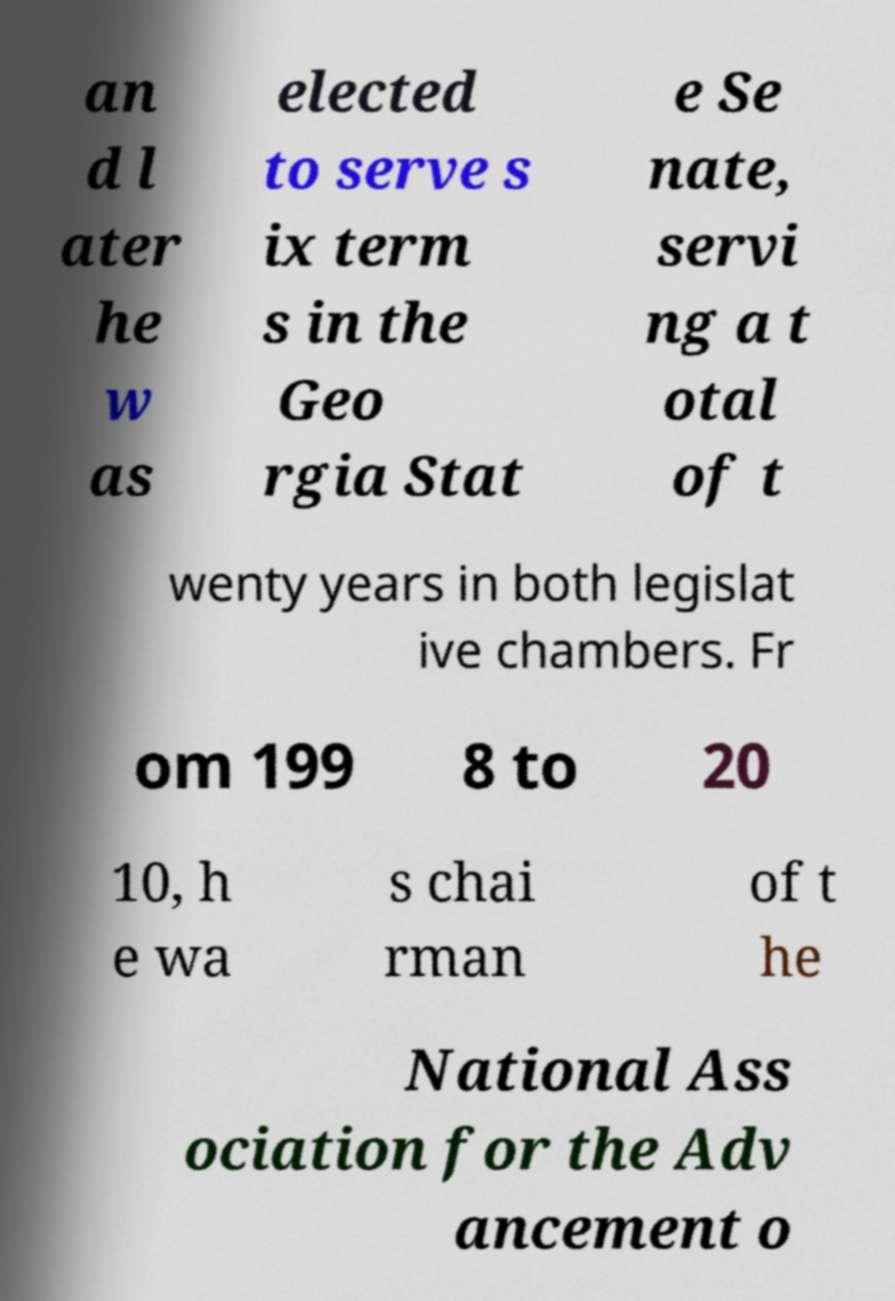Could you extract and type out the text from this image? an d l ater he w as elected to serve s ix term s in the Geo rgia Stat e Se nate, servi ng a t otal of t wenty years in both legislat ive chambers. Fr om 199 8 to 20 10, h e wa s chai rman of t he National Ass ociation for the Adv ancement o 